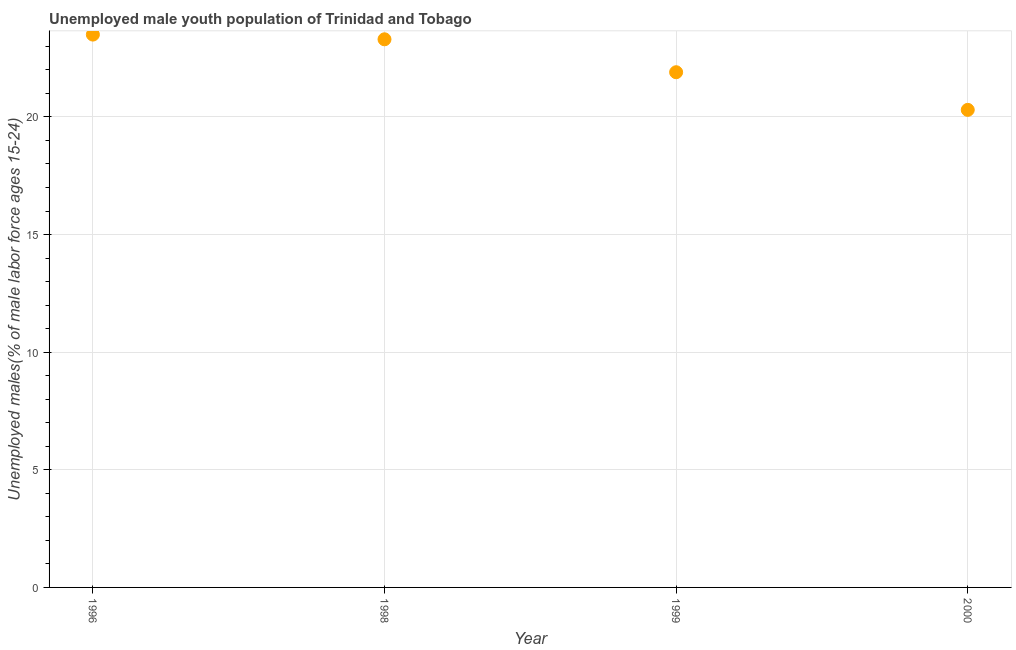What is the unemployed male youth in 2000?
Your answer should be compact. 20.3. Across all years, what is the maximum unemployed male youth?
Make the answer very short. 23.5. Across all years, what is the minimum unemployed male youth?
Keep it short and to the point. 20.3. In which year was the unemployed male youth maximum?
Provide a short and direct response. 1996. In which year was the unemployed male youth minimum?
Keep it short and to the point. 2000. What is the sum of the unemployed male youth?
Your answer should be very brief. 89. What is the difference between the unemployed male youth in 1999 and 2000?
Give a very brief answer. 1.6. What is the average unemployed male youth per year?
Your answer should be compact. 22.25. What is the median unemployed male youth?
Provide a short and direct response. 22.6. In how many years, is the unemployed male youth greater than 11 %?
Provide a short and direct response. 4. What is the ratio of the unemployed male youth in 1998 to that in 2000?
Provide a succinct answer. 1.15. Is the unemployed male youth in 1999 less than that in 2000?
Your response must be concise. No. What is the difference between the highest and the second highest unemployed male youth?
Ensure brevity in your answer.  0.2. Is the sum of the unemployed male youth in 1999 and 2000 greater than the maximum unemployed male youth across all years?
Offer a very short reply. Yes. What is the difference between the highest and the lowest unemployed male youth?
Your answer should be compact. 3.2. How many dotlines are there?
Make the answer very short. 1. How many years are there in the graph?
Offer a very short reply. 4. Does the graph contain any zero values?
Make the answer very short. No. What is the title of the graph?
Your answer should be very brief. Unemployed male youth population of Trinidad and Tobago. What is the label or title of the Y-axis?
Make the answer very short. Unemployed males(% of male labor force ages 15-24). What is the Unemployed males(% of male labor force ages 15-24) in 1998?
Your answer should be compact. 23.3. What is the Unemployed males(% of male labor force ages 15-24) in 1999?
Your answer should be compact. 21.9. What is the Unemployed males(% of male labor force ages 15-24) in 2000?
Your response must be concise. 20.3. What is the difference between the Unemployed males(% of male labor force ages 15-24) in 1998 and 1999?
Offer a very short reply. 1.4. What is the difference between the Unemployed males(% of male labor force ages 15-24) in 1998 and 2000?
Your response must be concise. 3. What is the difference between the Unemployed males(% of male labor force ages 15-24) in 1999 and 2000?
Offer a terse response. 1.6. What is the ratio of the Unemployed males(% of male labor force ages 15-24) in 1996 to that in 1998?
Offer a very short reply. 1.01. What is the ratio of the Unemployed males(% of male labor force ages 15-24) in 1996 to that in 1999?
Offer a terse response. 1.07. What is the ratio of the Unemployed males(% of male labor force ages 15-24) in 1996 to that in 2000?
Your response must be concise. 1.16. What is the ratio of the Unemployed males(% of male labor force ages 15-24) in 1998 to that in 1999?
Your answer should be very brief. 1.06. What is the ratio of the Unemployed males(% of male labor force ages 15-24) in 1998 to that in 2000?
Provide a short and direct response. 1.15. What is the ratio of the Unemployed males(% of male labor force ages 15-24) in 1999 to that in 2000?
Your answer should be very brief. 1.08. 